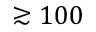<formula> <loc_0><loc_0><loc_500><loc_500>\gtrsim 1 0 0</formula> 